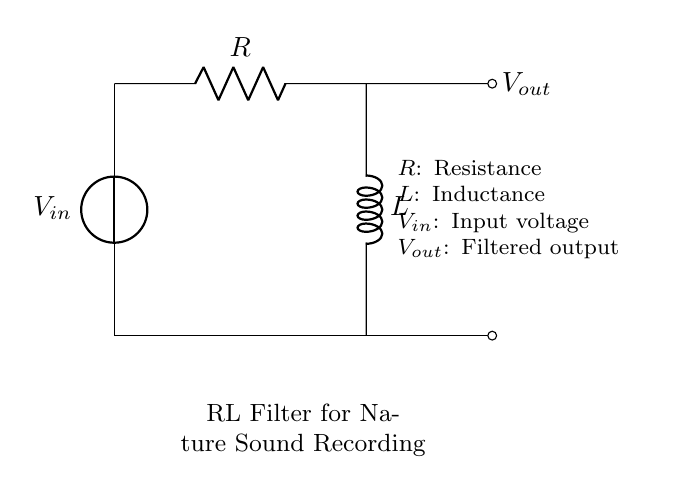What are the components in this circuit? The circuit contains a voltage source, a resistor, and an inductor. These three components are clearly labeled in the circuit diagram.
Answer: Voltage source, resistor, inductor What is the function of the resistor R in this circuit? The resistor R is used to limit the current flowing through the circuit, helping to control the voltage drop across the inductor L. This is important to ensure proper operation of the RL filter.
Answer: Limit current What is the output voltage Vout? The output voltage Vout is taken across the output terminals and is influenced by the values of R and L. It represents the filtered sound signal.
Answer: Filtered sound signal What happens to high-frequency interference in this circuit? The RL filter is designed to attenuate high-frequency interference effectively, thus allowing lower frequency signals (like nature sounds) to pass through with reduced noise.
Answer: Attenuation of high frequencies How does the inductor L contribute to filtering? The inductor L reacts to changes in current, storing energy in a magnetic field; it impedes rapid changes in current, which helps smooth out high-frequency signals, contributing to the filter function.
Answer: Impedes rapid current changes 